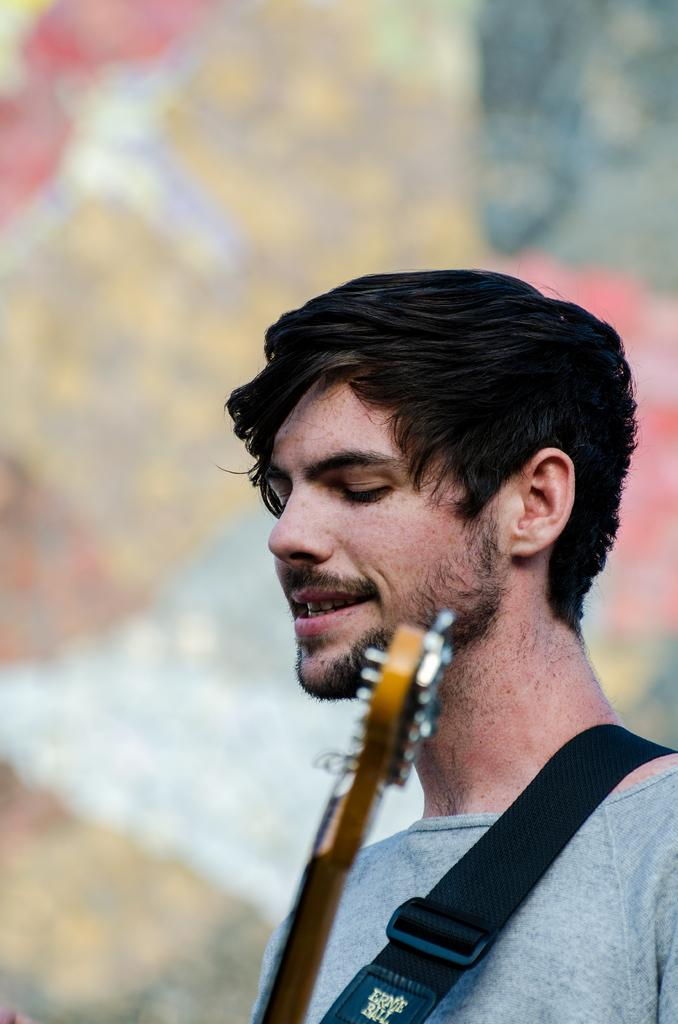What is the main subject of the image? There is a person in the image. Can you describe what the person might be doing? The person may be holding a musical instrument. What can be said about the background of the image? The background of the image is blurry. What type of silver hat is the person wearing in the image? There is no hat, silver or otherwise, visible in the image. 